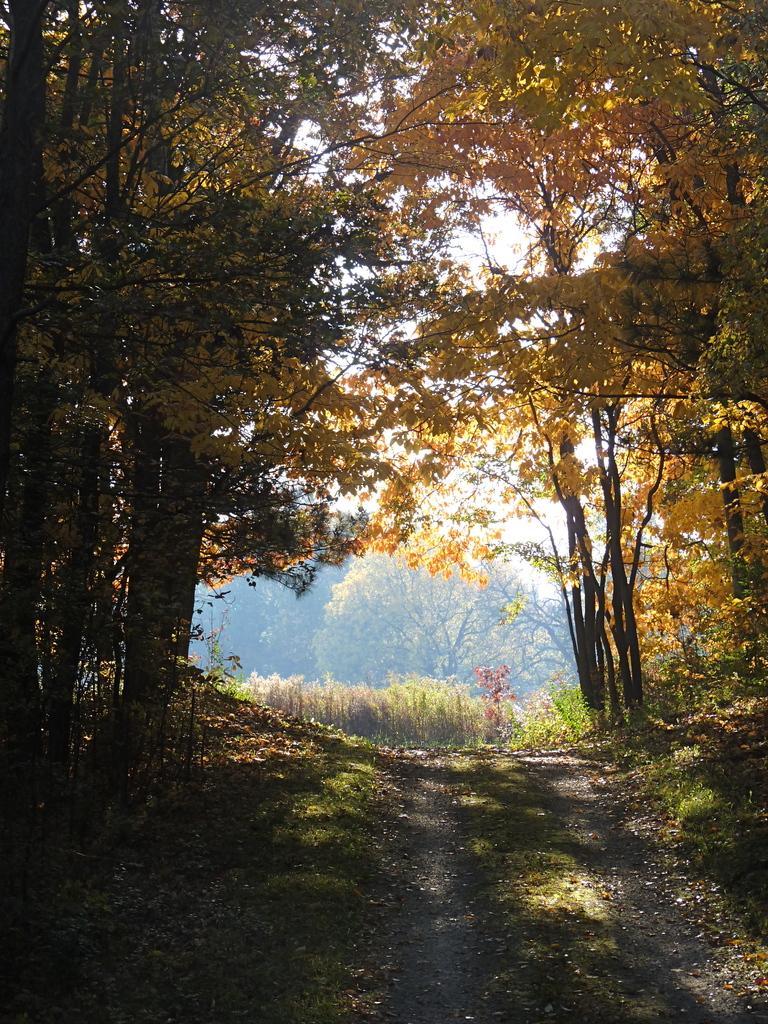Can you describe this image briefly? In the picture I can see the path, grass, dry leaves, trees and the sky in the background. 